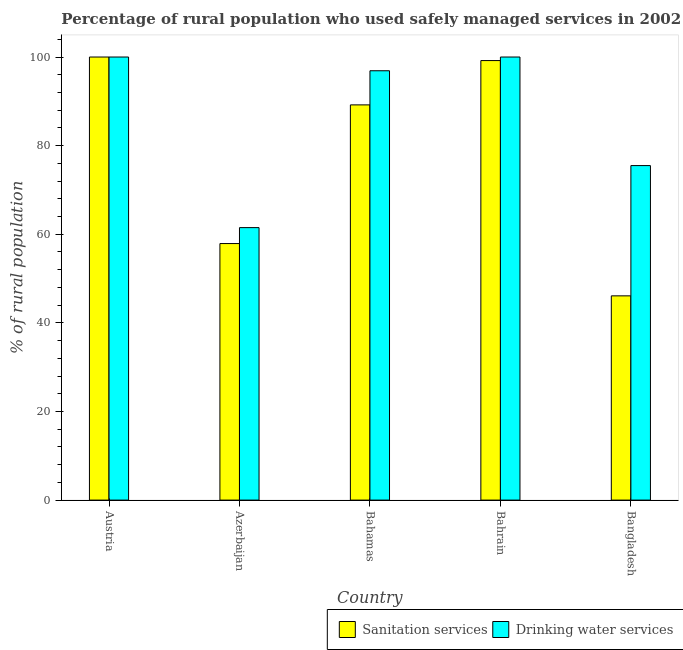How many different coloured bars are there?
Your answer should be compact. 2. Are the number of bars on each tick of the X-axis equal?
Offer a very short reply. Yes. How many bars are there on the 4th tick from the left?
Ensure brevity in your answer.  2. How many bars are there on the 1st tick from the right?
Your response must be concise. 2. What is the label of the 4th group of bars from the left?
Your response must be concise. Bahrain. In how many cases, is the number of bars for a given country not equal to the number of legend labels?
Provide a short and direct response. 0. What is the percentage of rural population who used drinking water services in Azerbaijan?
Provide a succinct answer. 61.5. Across all countries, what is the minimum percentage of rural population who used drinking water services?
Provide a short and direct response. 61.5. In which country was the percentage of rural population who used drinking water services minimum?
Ensure brevity in your answer.  Azerbaijan. What is the total percentage of rural population who used sanitation services in the graph?
Offer a terse response. 392.4. What is the difference between the percentage of rural population who used drinking water services in Azerbaijan and that in Bahrain?
Offer a very short reply. -38.5. What is the difference between the percentage of rural population who used sanitation services in Bahrain and the percentage of rural population who used drinking water services in Austria?
Keep it short and to the point. -0.8. What is the average percentage of rural population who used sanitation services per country?
Keep it short and to the point. 78.48. What is the difference between the percentage of rural population who used sanitation services and percentage of rural population who used drinking water services in Bahrain?
Make the answer very short. -0.8. In how many countries, is the percentage of rural population who used drinking water services greater than 24 %?
Offer a terse response. 5. What is the ratio of the percentage of rural population who used sanitation services in Austria to that in Bahrain?
Your answer should be compact. 1.01. What is the difference between the highest and the second highest percentage of rural population who used sanitation services?
Keep it short and to the point. 0.8. What is the difference between the highest and the lowest percentage of rural population who used sanitation services?
Offer a very short reply. 53.9. In how many countries, is the percentage of rural population who used drinking water services greater than the average percentage of rural population who used drinking water services taken over all countries?
Give a very brief answer. 3. What does the 2nd bar from the left in Bahrain represents?
Ensure brevity in your answer.  Drinking water services. What does the 1st bar from the right in Bahamas represents?
Ensure brevity in your answer.  Drinking water services. Are all the bars in the graph horizontal?
Your answer should be very brief. No. How many countries are there in the graph?
Keep it short and to the point. 5. Are the values on the major ticks of Y-axis written in scientific E-notation?
Give a very brief answer. No. Does the graph contain any zero values?
Make the answer very short. No. Does the graph contain grids?
Ensure brevity in your answer.  No. Where does the legend appear in the graph?
Give a very brief answer. Bottom right. What is the title of the graph?
Provide a succinct answer. Percentage of rural population who used safely managed services in 2002. Does "Primary completion rate" appear as one of the legend labels in the graph?
Ensure brevity in your answer.  No. What is the label or title of the X-axis?
Your answer should be compact. Country. What is the label or title of the Y-axis?
Provide a short and direct response. % of rural population. What is the % of rural population in Sanitation services in Azerbaijan?
Make the answer very short. 57.9. What is the % of rural population of Drinking water services in Azerbaijan?
Offer a terse response. 61.5. What is the % of rural population of Sanitation services in Bahamas?
Provide a short and direct response. 89.2. What is the % of rural population of Drinking water services in Bahamas?
Ensure brevity in your answer.  96.9. What is the % of rural population of Sanitation services in Bahrain?
Offer a very short reply. 99.2. What is the % of rural population of Sanitation services in Bangladesh?
Keep it short and to the point. 46.1. What is the % of rural population of Drinking water services in Bangladesh?
Make the answer very short. 75.5. Across all countries, what is the maximum % of rural population in Drinking water services?
Your response must be concise. 100. Across all countries, what is the minimum % of rural population in Sanitation services?
Offer a very short reply. 46.1. Across all countries, what is the minimum % of rural population of Drinking water services?
Keep it short and to the point. 61.5. What is the total % of rural population in Sanitation services in the graph?
Your answer should be compact. 392.4. What is the total % of rural population in Drinking water services in the graph?
Make the answer very short. 433.9. What is the difference between the % of rural population in Sanitation services in Austria and that in Azerbaijan?
Offer a terse response. 42.1. What is the difference between the % of rural population of Drinking water services in Austria and that in Azerbaijan?
Make the answer very short. 38.5. What is the difference between the % of rural population of Sanitation services in Austria and that in Bahrain?
Offer a terse response. 0.8. What is the difference between the % of rural population of Sanitation services in Austria and that in Bangladesh?
Keep it short and to the point. 53.9. What is the difference between the % of rural population in Sanitation services in Azerbaijan and that in Bahamas?
Keep it short and to the point. -31.3. What is the difference between the % of rural population of Drinking water services in Azerbaijan and that in Bahamas?
Your answer should be compact. -35.4. What is the difference between the % of rural population in Sanitation services in Azerbaijan and that in Bahrain?
Give a very brief answer. -41.3. What is the difference between the % of rural population of Drinking water services in Azerbaijan and that in Bahrain?
Offer a very short reply. -38.5. What is the difference between the % of rural population of Sanitation services in Azerbaijan and that in Bangladesh?
Provide a succinct answer. 11.8. What is the difference between the % of rural population in Drinking water services in Azerbaijan and that in Bangladesh?
Make the answer very short. -14. What is the difference between the % of rural population in Sanitation services in Bahamas and that in Bangladesh?
Keep it short and to the point. 43.1. What is the difference between the % of rural population of Drinking water services in Bahamas and that in Bangladesh?
Give a very brief answer. 21.4. What is the difference between the % of rural population of Sanitation services in Bahrain and that in Bangladesh?
Provide a succinct answer. 53.1. What is the difference between the % of rural population in Sanitation services in Austria and the % of rural population in Drinking water services in Azerbaijan?
Your answer should be very brief. 38.5. What is the difference between the % of rural population of Sanitation services in Azerbaijan and the % of rural population of Drinking water services in Bahamas?
Your answer should be compact. -39. What is the difference between the % of rural population of Sanitation services in Azerbaijan and the % of rural population of Drinking water services in Bahrain?
Give a very brief answer. -42.1. What is the difference between the % of rural population of Sanitation services in Azerbaijan and the % of rural population of Drinking water services in Bangladesh?
Your response must be concise. -17.6. What is the difference between the % of rural population of Sanitation services in Bahrain and the % of rural population of Drinking water services in Bangladesh?
Provide a short and direct response. 23.7. What is the average % of rural population of Sanitation services per country?
Offer a terse response. 78.48. What is the average % of rural population of Drinking water services per country?
Offer a terse response. 86.78. What is the difference between the % of rural population of Sanitation services and % of rural population of Drinking water services in Austria?
Provide a succinct answer. 0. What is the difference between the % of rural population in Sanitation services and % of rural population in Drinking water services in Bahamas?
Keep it short and to the point. -7.7. What is the difference between the % of rural population of Sanitation services and % of rural population of Drinking water services in Bahrain?
Your answer should be compact. -0.8. What is the difference between the % of rural population in Sanitation services and % of rural population in Drinking water services in Bangladesh?
Your answer should be compact. -29.4. What is the ratio of the % of rural population of Sanitation services in Austria to that in Azerbaijan?
Your answer should be compact. 1.73. What is the ratio of the % of rural population in Drinking water services in Austria to that in Azerbaijan?
Your answer should be compact. 1.63. What is the ratio of the % of rural population of Sanitation services in Austria to that in Bahamas?
Provide a short and direct response. 1.12. What is the ratio of the % of rural population in Drinking water services in Austria to that in Bahamas?
Offer a terse response. 1.03. What is the ratio of the % of rural population of Sanitation services in Austria to that in Bahrain?
Offer a very short reply. 1.01. What is the ratio of the % of rural population of Drinking water services in Austria to that in Bahrain?
Offer a terse response. 1. What is the ratio of the % of rural population of Sanitation services in Austria to that in Bangladesh?
Give a very brief answer. 2.17. What is the ratio of the % of rural population of Drinking water services in Austria to that in Bangladesh?
Offer a very short reply. 1.32. What is the ratio of the % of rural population in Sanitation services in Azerbaijan to that in Bahamas?
Offer a terse response. 0.65. What is the ratio of the % of rural population of Drinking water services in Azerbaijan to that in Bahamas?
Provide a short and direct response. 0.63. What is the ratio of the % of rural population in Sanitation services in Azerbaijan to that in Bahrain?
Offer a terse response. 0.58. What is the ratio of the % of rural population of Drinking water services in Azerbaijan to that in Bahrain?
Your response must be concise. 0.61. What is the ratio of the % of rural population of Sanitation services in Azerbaijan to that in Bangladesh?
Your answer should be compact. 1.26. What is the ratio of the % of rural population of Drinking water services in Azerbaijan to that in Bangladesh?
Your answer should be compact. 0.81. What is the ratio of the % of rural population of Sanitation services in Bahamas to that in Bahrain?
Ensure brevity in your answer.  0.9. What is the ratio of the % of rural population in Sanitation services in Bahamas to that in Bangladesh?
Offer a very short reply. 1.93. What is the ratio of the % of rural population in Drinking water services in Bahamas to that in Bangladesh?
Your response must be concise. 1.28. What is the ratio of the % of rural population in Sanitation services in Bahrain to that in Bangladesh?
Your response must be concise. 2.15. What is the ratio of the % of rural population of Drinking water services in Bahrain to that in Bangladesh?
Keep it short and to the point. 1.32. What is the difference between the highest and the second highest % of rural population of Drinking water services?
Your response must be concise. 0. What is the difference between the highest and the lowest % of rural population in Sanitation services?
Ensure brevity in your answer.  53.9. What is the difference between the highest and the lowest % of rural population of Drinking water services?
Give a very brief answer. 38.5. 